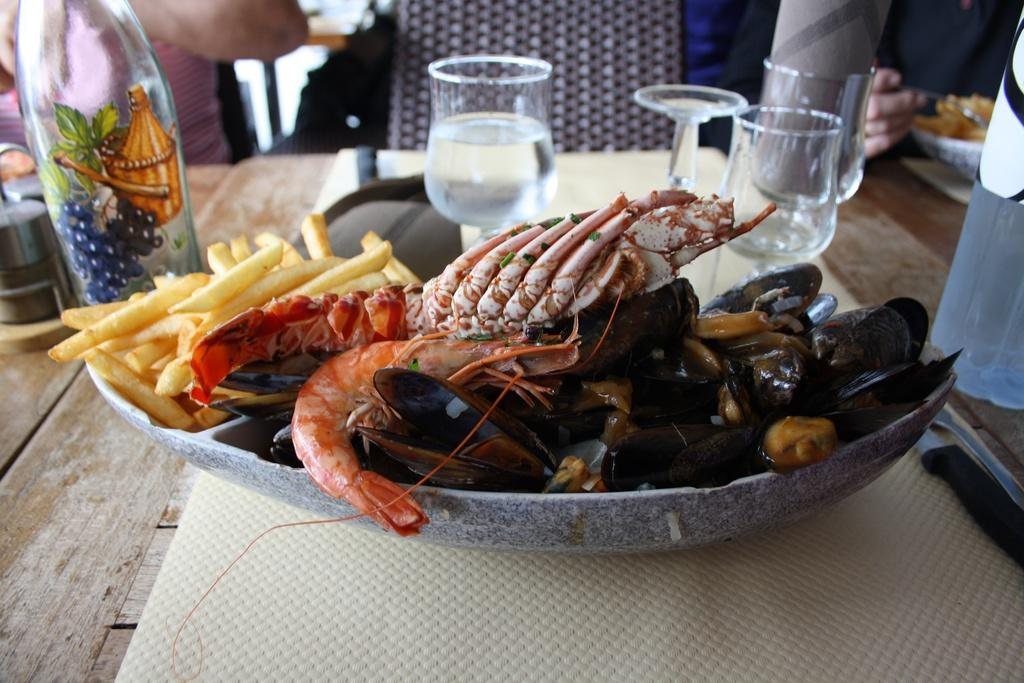What type of food is on the left side of the image? There are french fries on the left side of the image. What is in the plate in the middle of the image? There are prawns in a plate in the middle of the image. What type of glasses are present in the image? There are wine glasses in the image. Where is the knife located in the image? There is no knife present in the image. What color is the scarf draped over the wine glasses? There is no scarf present in the image. 